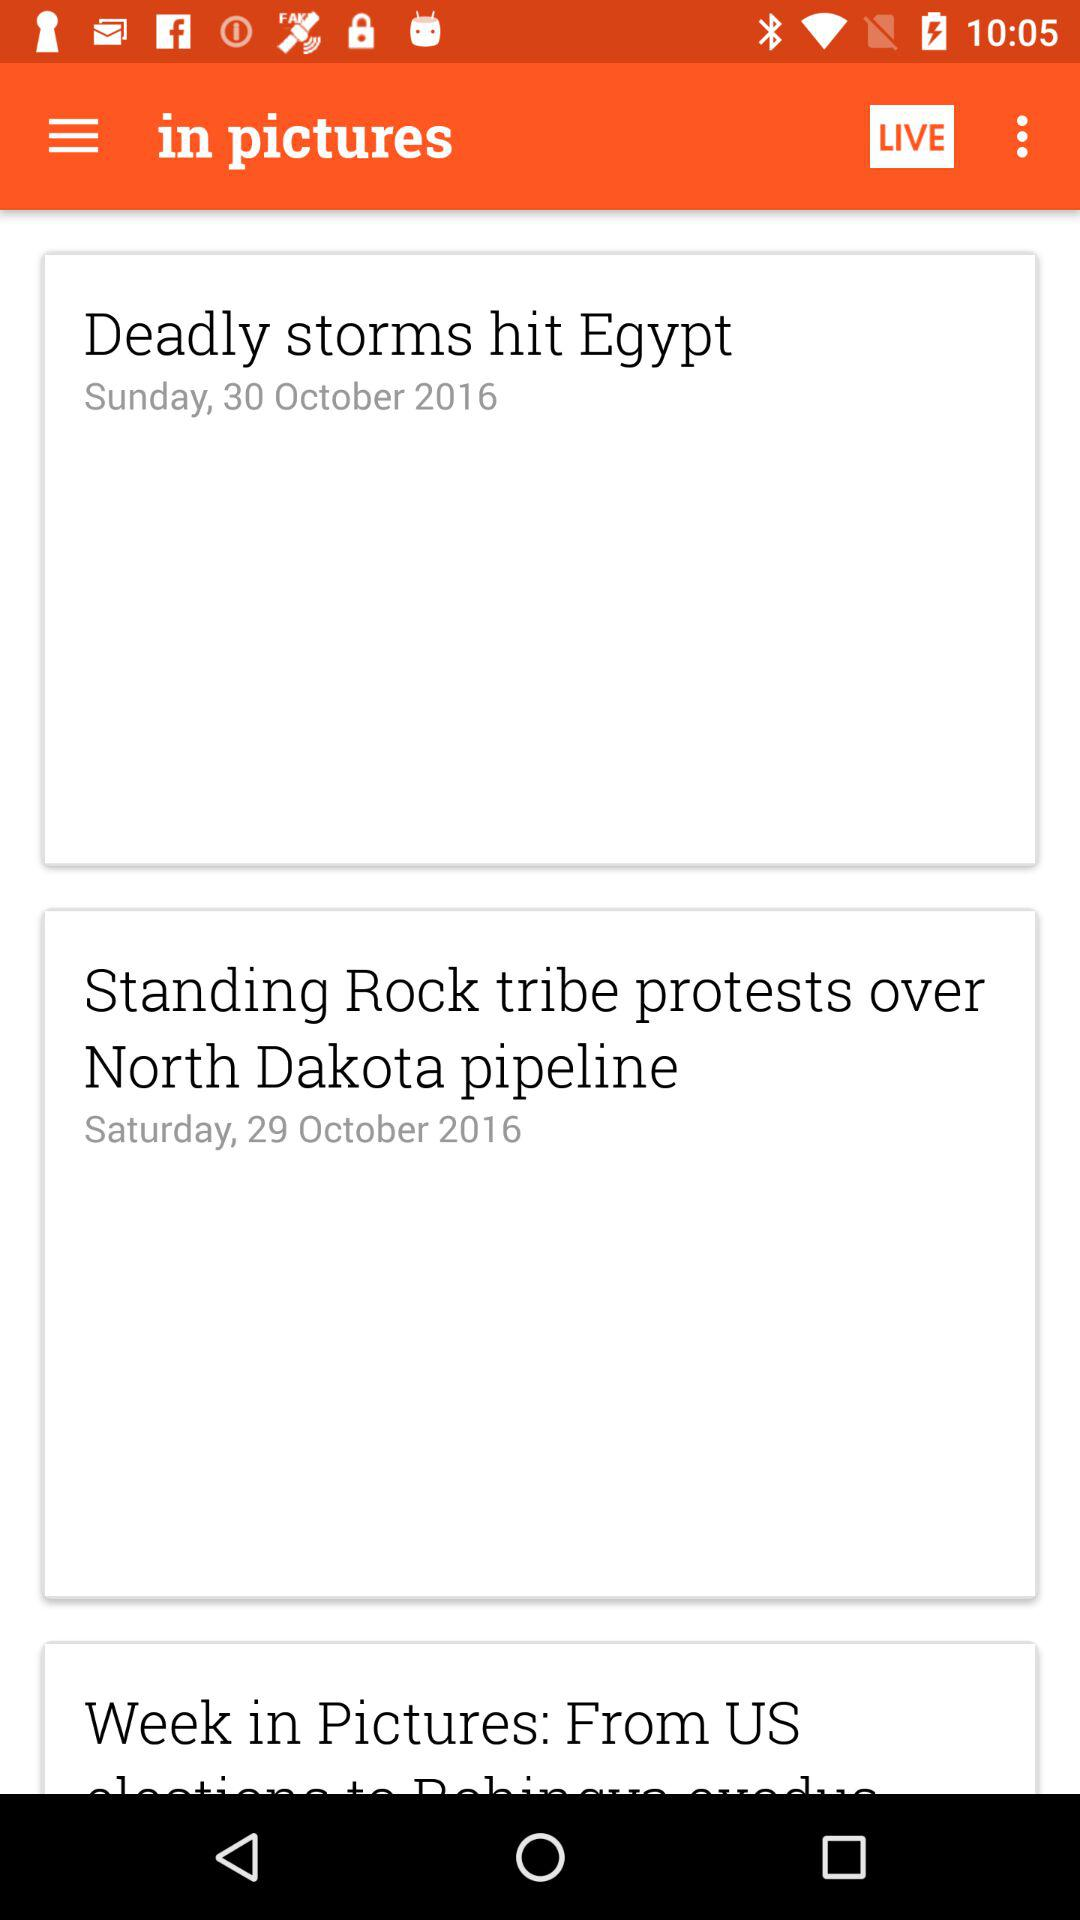What was the 29 October 2016 headline? The headline was "Standing Rock tribe protests over North Dakota pipeline". 